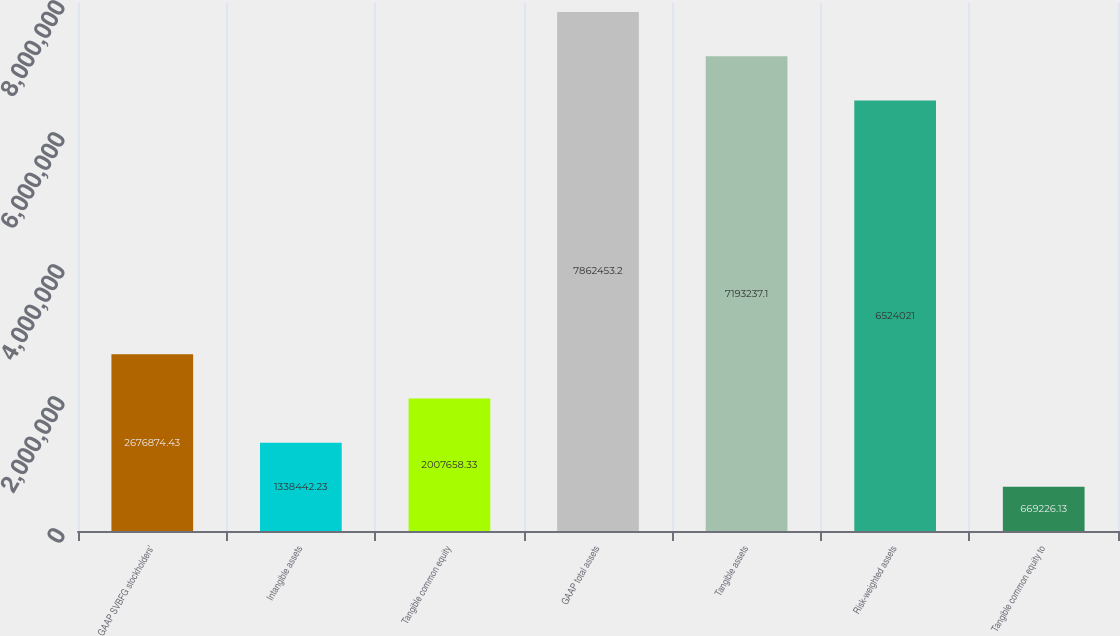Convert chart to OTSL. <chart><loc_0><loc_0><loc_500><loc_500><bar_chart><fcel>GAAP SVBFG stockholders'<fcel>Intangible assets<fcel>Tangible common equity<fcel>GAAP total assets<fcel>Tangible assets<fcel>Risk-weighted assets<fcel>Tangible common equity to<nl><fcel>2.67687e+06<fcel>1.33844e+06<fcel>2.00766e+06<fcel>7.86245e+06<fcel>7.19324e+06<fcel>6.52402e+06<fcel>669226<nl></chart> 